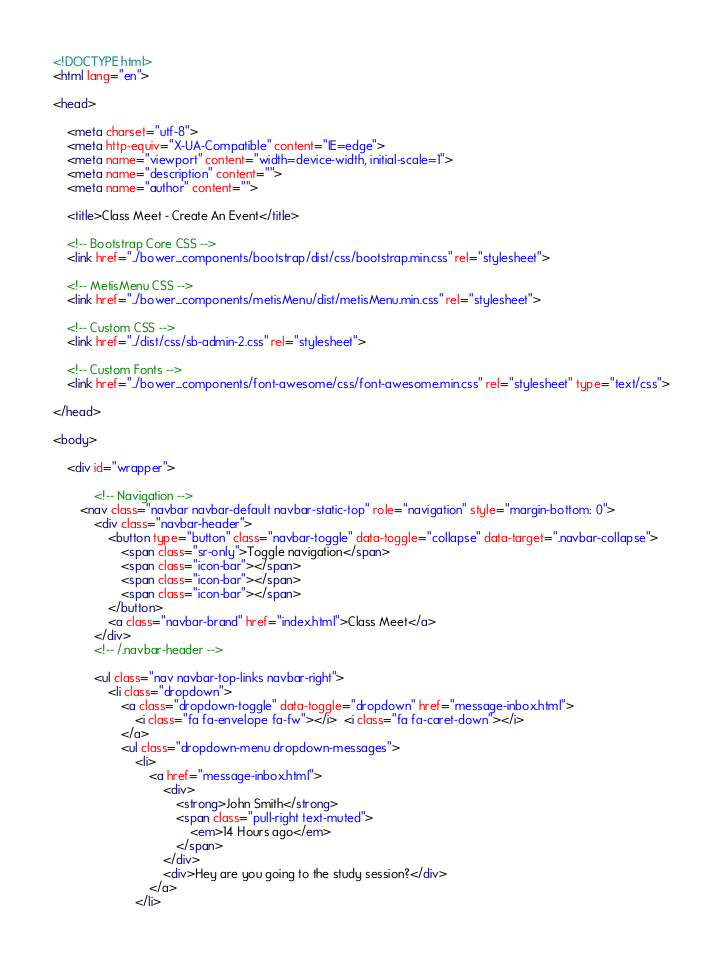<code> <loc_0><loc_0><loc_500><loc_500><_HTML_><!DOCTYPE html>
<html lang="en">

<head>

    <meta charset="utf-8">
    <meta http-equiv="X-UA-Compatible" content="IE=edge">
    <meta name="viewport" content="width=device-width, initial-scale=1">
    <meta name="description" content="">
    <meta name="author" content="">

    <title>Class Meet - Create An Event</title>

    <!-- Bootstrap Core CSS -->
    <link href="../bower_components/bootstrap/dist/css/bootstrap.min.css" rel="stylesheet">

    <!-- MetisMenu CSS -->
    <link href="../bower_components/metisMenu/dist/metisMenu.min.css" rel="stylesheet">

    <!-- Custom CSS -->
    <link href="../dist/css/sb-admin-2.css" rel="stylesheet">

    <!-- Custom Fonts -->
    <link href="../bower_components/font-awesome/css/font-awesome.min.css" rel="stylesheet" type="text/css">

</head>

<body>

    <div id="wrapper">

            <!-- Navigation -->
        <nav class="navbar navbar-default navbar-static-top" role="navigation" style="margin-bottom: 0">
            <div class="navbar-header">
                <button type="button" class="navbar-toggle" data-toggle="collapse" data-target=".navbar-collapse">
                    <span class="sr-only">Toggle navigation</span>
                    <span class="icon-bar"></span>
                    <span class="icon-bar"></span>
                    <span class="icon-bar"></span>
                </button>
                <a class="navbar-brand" href="index.html">Class Meet</a>
            </div>
            <!-- /.navbar-header -->

            <ul class="nav navbar-top-links navbar-right">
                <li class="dropdown">
                    <a class="dropdown-toggle" data-toggle="dropdown" href="message-inbox.html">
                        <i class="fa fa-envelope fa-fw"></i>  <i class="fa fa-caret-down"></i>
                    </a>
                    <ul class="dropdown-menu dropdown-messages">
                        <li>
                            <a href="message-inbox.html">
                                <div>
                                    <strong>John Smith</strong>
                                    <span class="pull-right text-muted">
                                        <em>14 Hours ago</em>
                                    </span>
                                </div>
                                <div>Hey are you going to the study session?</div>
                            </a>
                        </li></code> 